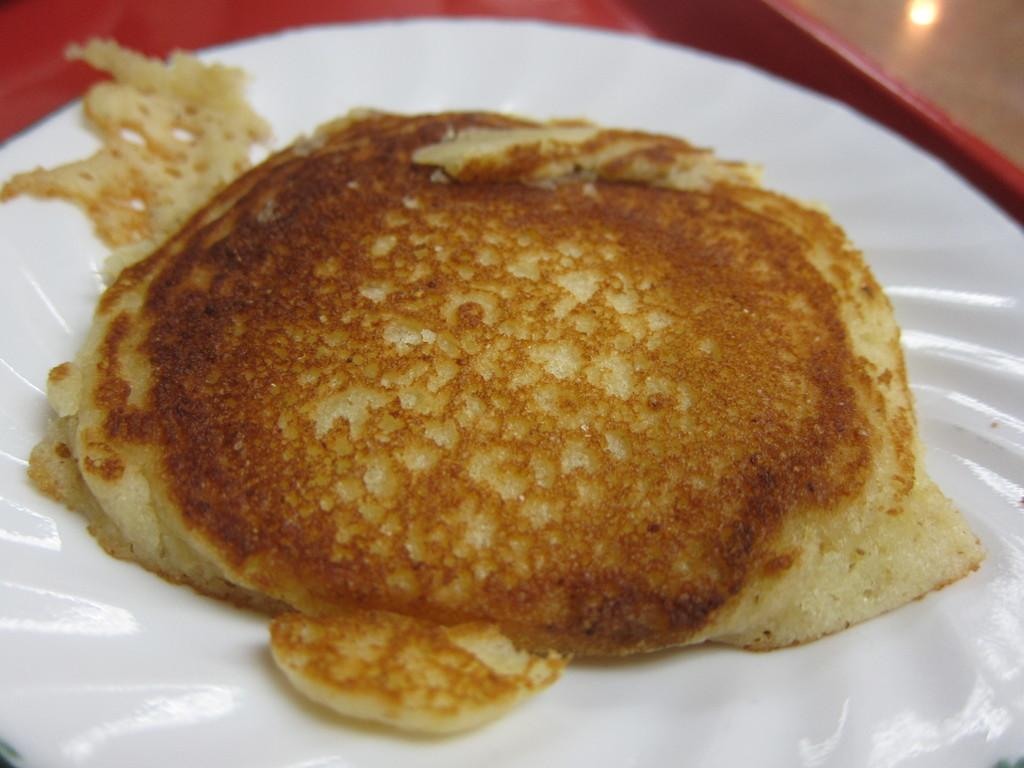What is present on the plate in the image? There is food on a plate in the image. What type of cub can be seen playing with a yoke in the image? There is no cub or yoke present in the image; it features a plate of food. 